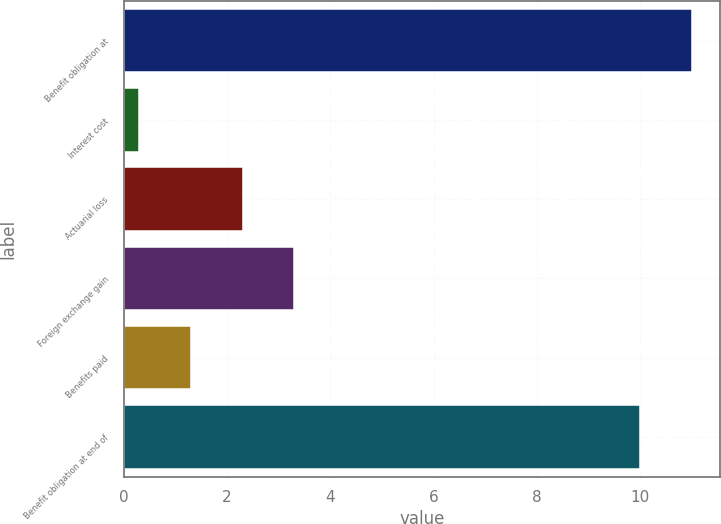Convert chart to OTSL. <chart><loc_0><loc_0><loc_500><loc_500><bar_chart><fcel>Benefit obligation at<fcel>Interest cost<fcel>Actuarial loss<fcel>Foreign exchange gain<fcel>Benefits paid<fcel>Benefit obligation at end of<nl><fcel>11<fcel>0.3<fcel>2.3<fcel>3.3<fcel>1.3<fcel>10<nl></chart> 